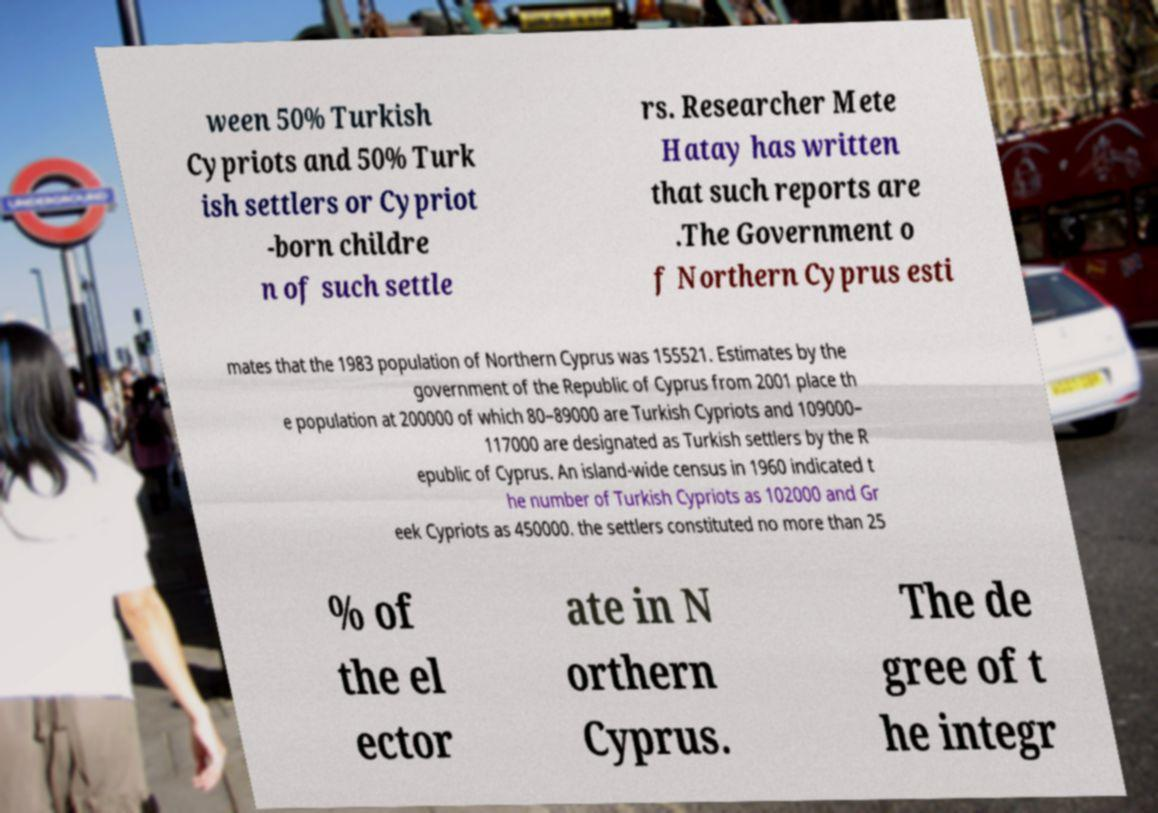Can you read and provide the text displayed in the image?This photo seems to have some interesting text. Can you extract and type it out for me? ween 50% Turkish Cypriots and 50% Turk ish settlers or Cypriot -born childre n of such settle rs. Researcher Mete Hatay has written that such reports are .The Government o f Northern Cyprus esti mates that the 1983 population of Northern Cyprus was 155521. Estimates by the government of the Republic of Cyprus from 2001 place th e population at 200000 of which 80–89000 are Turkish Cypriots and 109000– 117000 are designated as Turkish settlers by the R epublic of Cyprus. An island-wide census in 1960 indicated t he number of Turkish Cypriots as 102000 and Gr eek Cypriots as 450000. the settlers constituted no more than 25 % of the el ector ate in N orthern Cyprus. The de gree of t he integr 